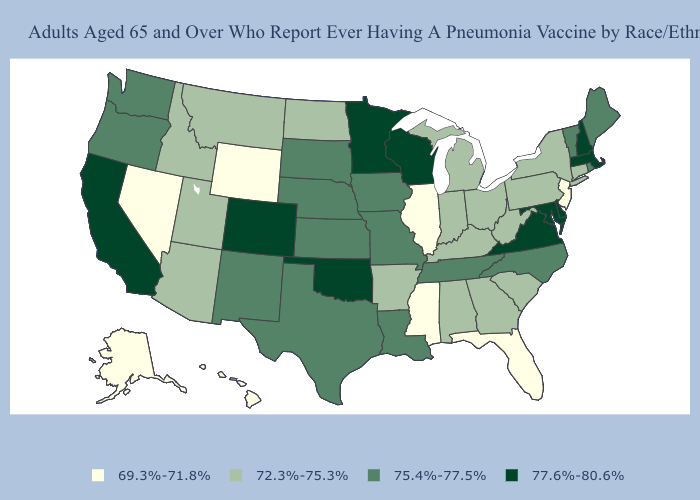What is the lowest value in the USA?
Keep it brief. 69.3%-71.8%. Name the states that have a value in the range 77.6%-80.6%?
Short answer required. California, Colorado, Delaware, Maryland, Massachusetts, Minnesota, New Hampshire, Oklahoma, Virginia, Wisconsin. Among the states that border Oregon , which have the lowest value?
Write a very short answer. Nevada. Among the states that border Pennsylvania , does New Jersey have the highest value?
Be succinct. No. How many symbols are there in the legend?
Quick response, please. 4. Name the states that have a value in the range 69.3%-71.8%?
Keep it brief. Alaska, Florida, Hawaii, Illinois, Mississippi, Nevada, New Jersey, Wyoming. Name the states that have a value in the range 72.3%-75.3%?
Give a very brief answer. Alabama, Arizona, Arkansas, Connecticut, Georgia, Idaho, Indiana, Kentucky, Michigan, Montana, New York, North Dakota, Ohio, Pennsylvania, South Carolina, Utah, West Virginia. Does the first symbol in the legend represent the smallest category?
Concise answer only. Yes. Name the states that have a value in the range 69.3%-71.8%?
Short answer required. Alaska, Florida, Hawaii, Illinois, Mississippi, Nevada, New Jersey, Wyoming. What is the value of West Virginia?
Give a very brief answer. 72.3%-75.3%. How many symbols are there in the legend?
Be succinct. 4. Name the states that have a value in the range 77.6%-80.6%?
Short answer required. California, Colorado, Delaware, Maryland, Massachusetts, Minnesota, New Hampshire, Oklahoma, Virginia, Wisconsin. Name the states that have a value in the range 77.6%-80.6%?
Concise answer only. California, Colorado, Delaware, Maryland, Massachusetts, Minnesota, New Hampshire, Oklahoma, Virginia, Wisconsin. Name the states that have a value in the range 75.4%-77.5%?
Write a very short answer. Iowa, Kansas, Louisiana, Maine, Missouri, Nebraska, New Mexico, North Carolina, Oregon, Rhode Island, South Dakota, Tennessee, Texas, Vermont, Washington. Name the states that have a value in the range 72.3%-75.3%?
Give a very brief answer. Alabama, Arizona, Arkansas, Connecticut, Georgia, Idaho, Indiana, Kentucky, Michigan, Montana, New York, North Dakota, Ohio, Pennsylvania, South Carolina, Utah, West Virginia. 